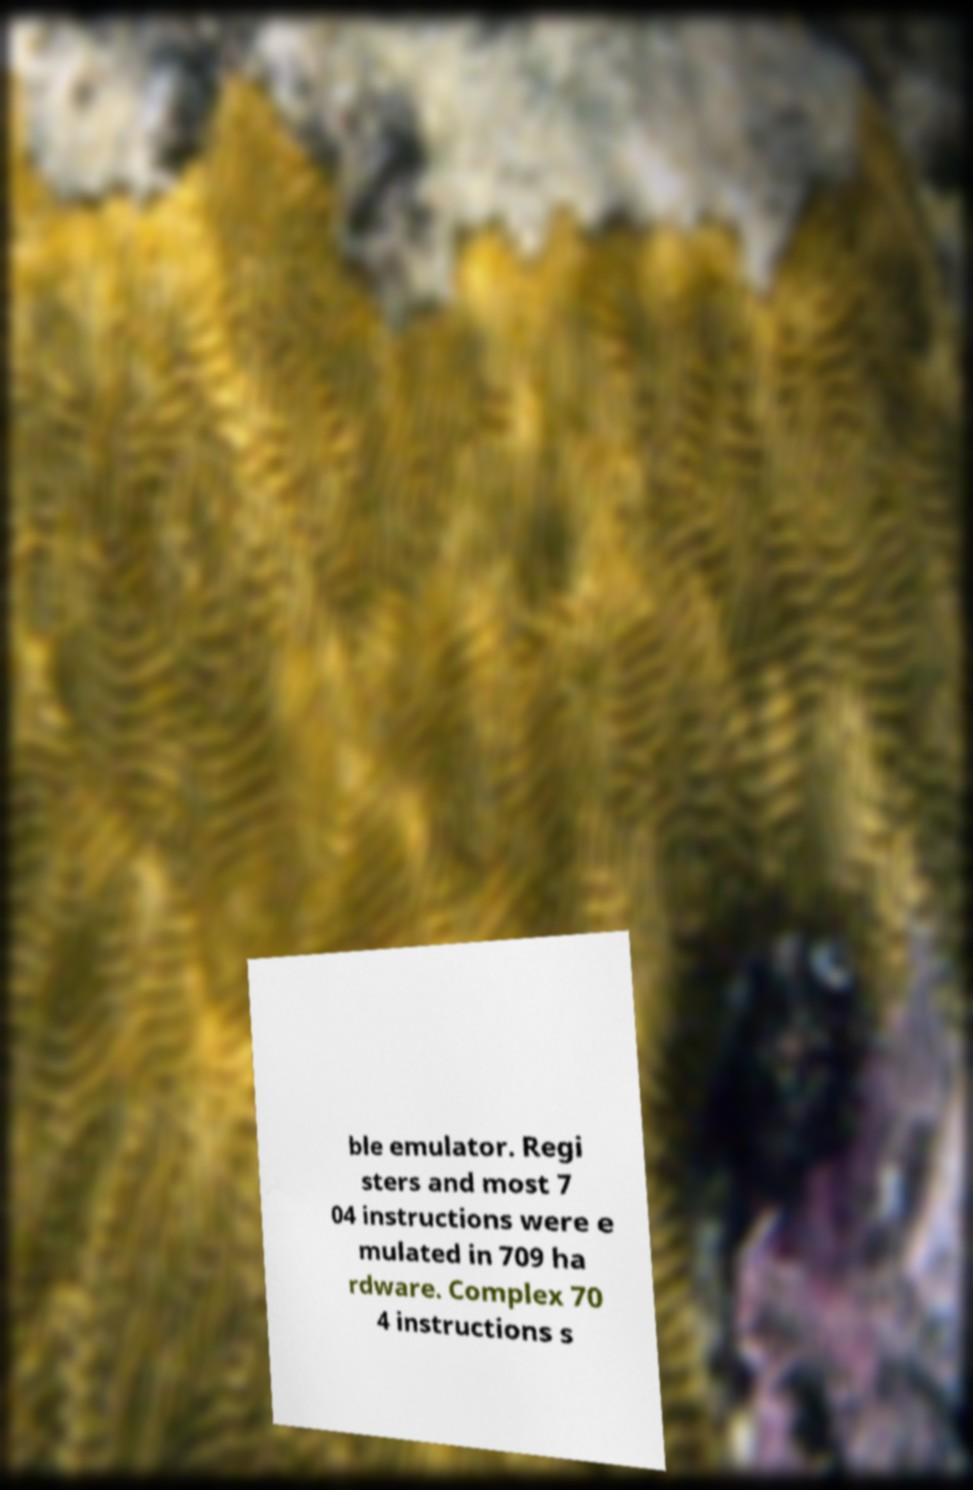Please read and relay the text visible in this image. What does it say? ble emulator. Regi sters and most 7 04 instructions were e mulated in 709 ha rdware. Complex 70 4 instructions s 